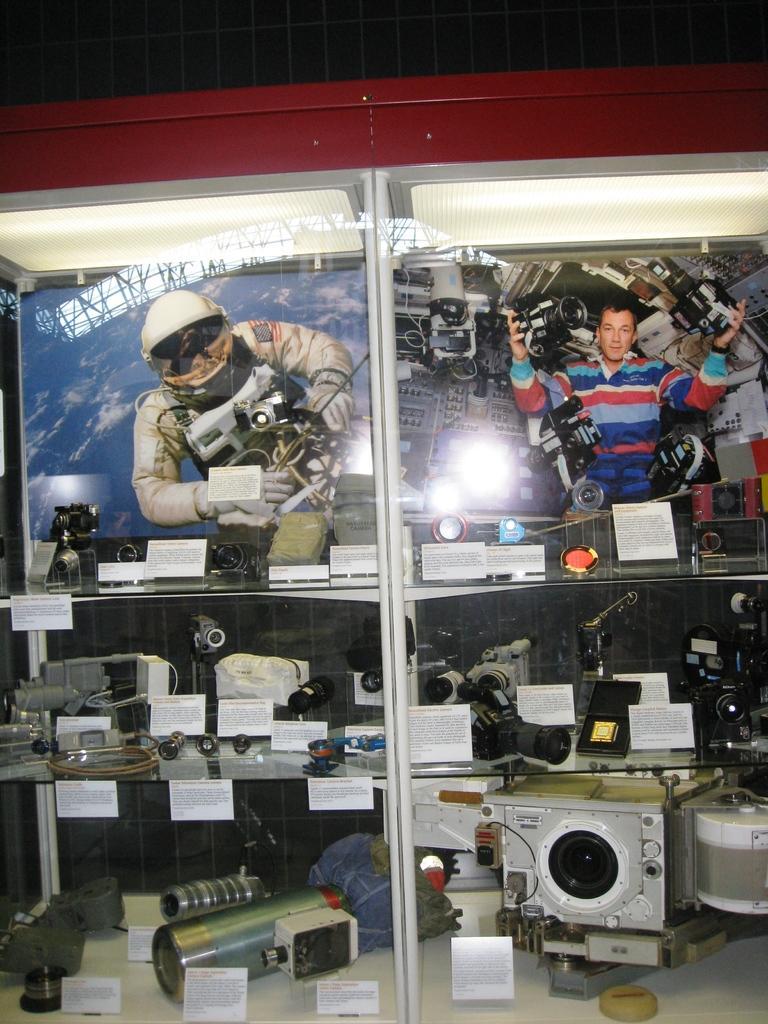How would you summarize this image in a sentence or two? In this image there are so many cameras,lens and some objects kept in the glass shelf. In front of them there is a small sticker on which there is some text. At the top there are two pictures in the background. On the right side there is a man. On the left side there is a person who is wearing the space jacket. 